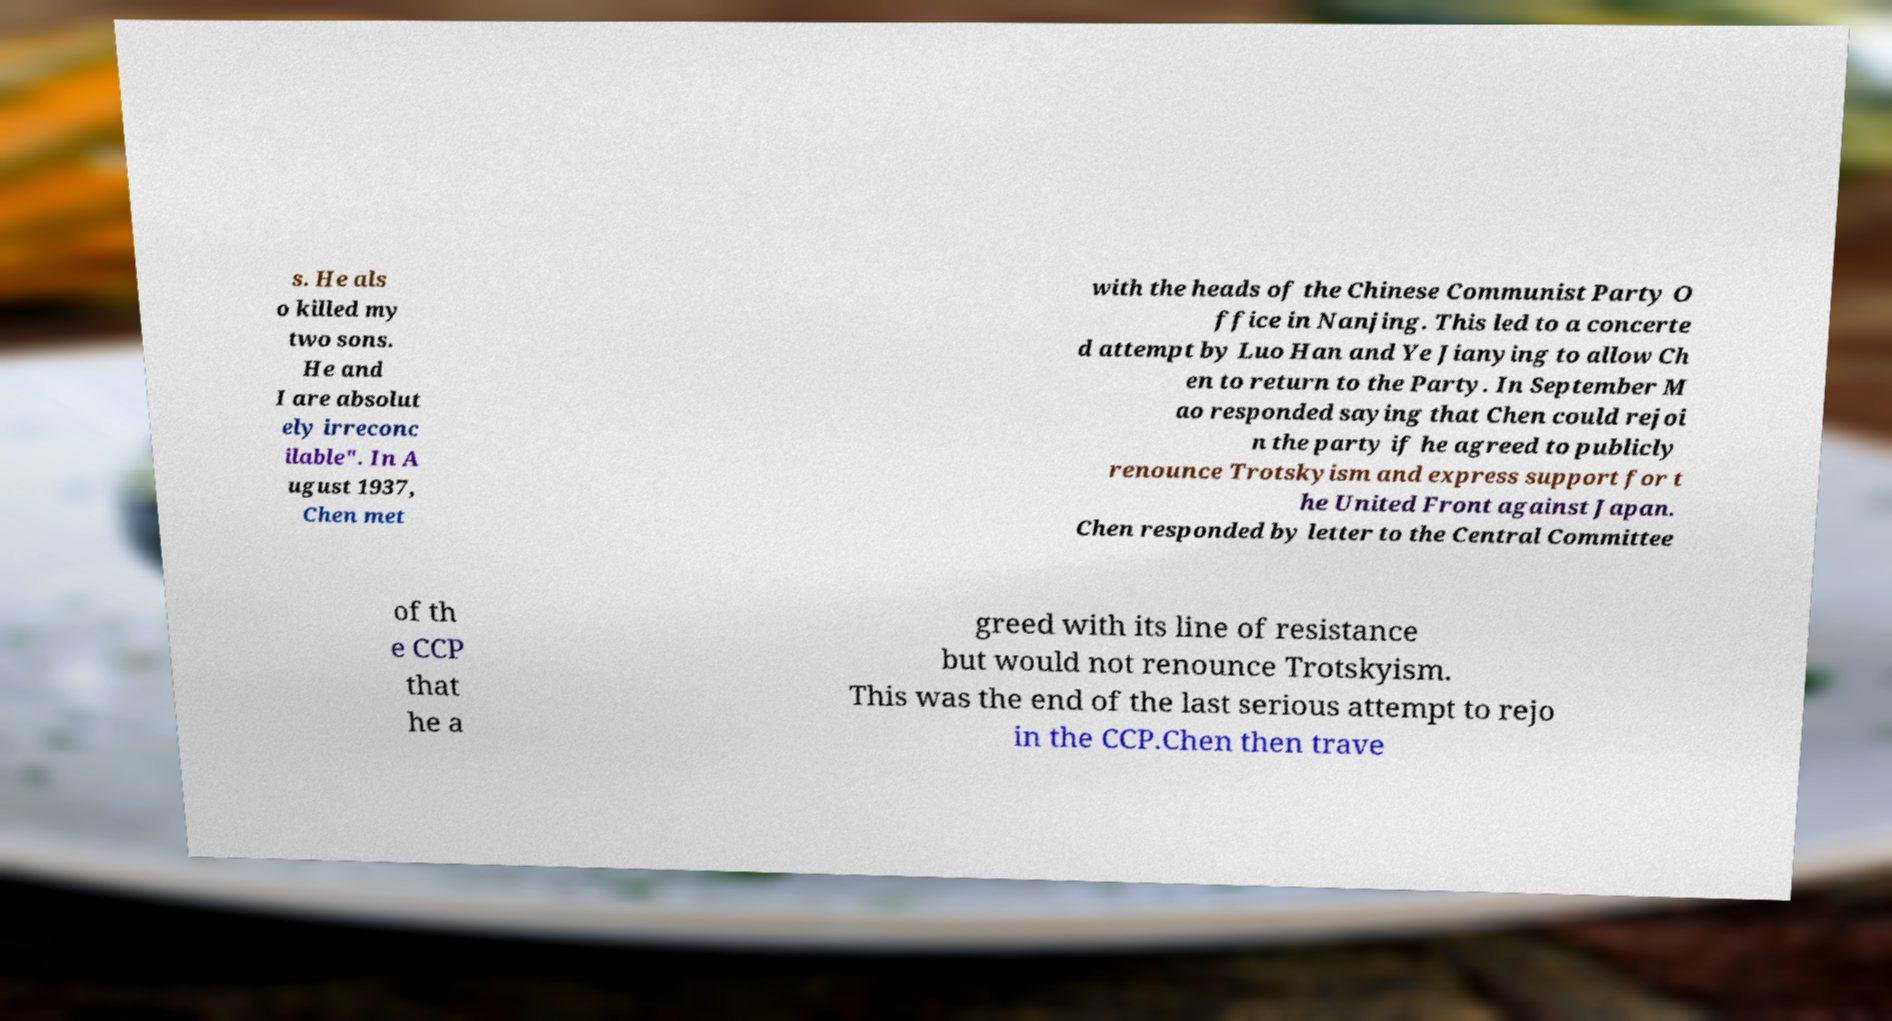Please read and relay the text visible in this image. What does it say? s. He als o killed my two sons. He and I are absolut ely irreconc ilable". In A ugust 1937, Chen met with the heads of the Chinese Communist Party O ffice in Nanjing. This led to a concerte d attempt by Luo Han and Ye Jianying to allow Ch en to return to the Party. In September M ao responded saying that Chen could rejoi n the party if he agreed to publicly renounce Trotskyism and express support for t he United Front against Japan. Chen responded by letter to the Central Committee of th e CCP that he a greed with its line of resistance but would not renounce Trotskyism. This was the end of the last serious attempt to rejo in the CCP.Chen then trave 